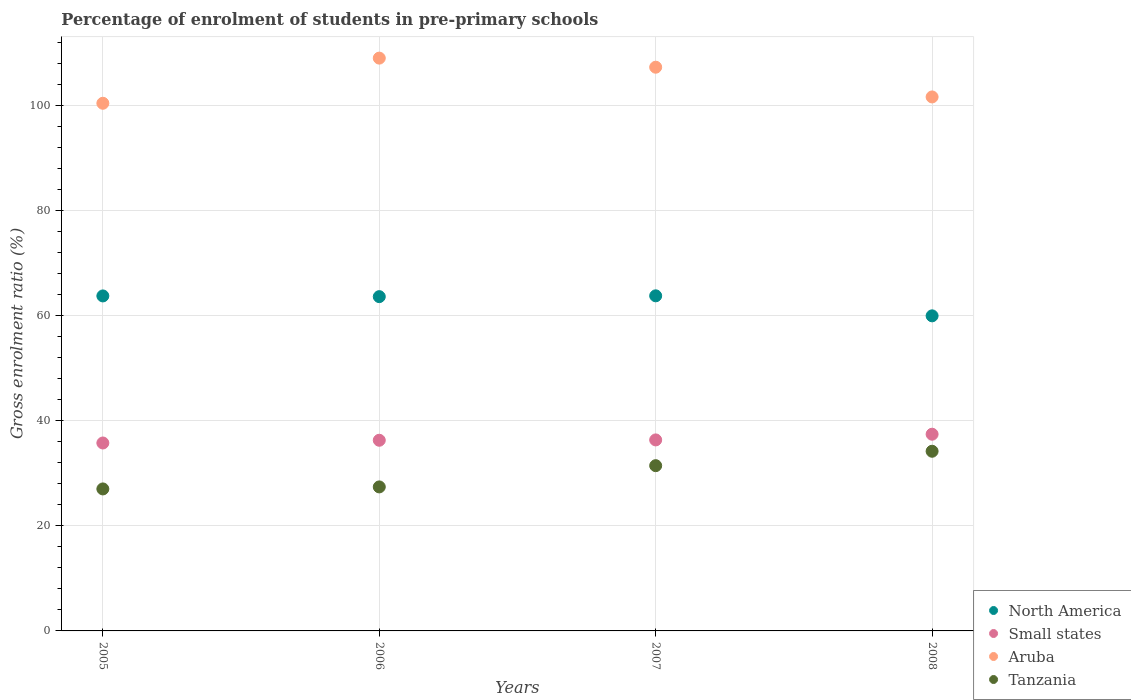How many different coloured dotlines are there?
Your answer should be compact. 4. What is the percentage of students enrolled in pre-primary schools in North America in 2005?
Offer a very short reply. 63.76. Across all years, what is the maximum percentage of students enrolled in pre-primary schools in Tanzania?
Your answer should be very brief. 34.2. Across all years, what is the minimum percentage of students enrolled in pre-primary schools in North America?
Give a very brief answer. 59.97. In which year was the percentage of students enrolled in pre-primary schools in North America minimum?
Ensure brevity in your answer.  2008. What is the total percentage of students enrolled in pre-primary schools in Small states in the graph?
Your answer should be very brief. 145.85. What is the difference between the percentage of students enrolled in pre-primary schools in North America in 2005 and that in 2007?
Offer a very short reply. -0.02. What is the difference between the percentage of students enrolled in pre-primary schools in North America in 2006 and the percentage of students enrolled in pre-primary schools in Aruba in 2005?
Keep it short and to the point. -36.8. What is the average percentage of students enrolled in pre-primary schools in Aruba per year?
Your answer should be very brief. 104.59. In the year 2007, what is the difference between the percentage of students enrolled in pre-primary schools in Aruba and percentage of students enrolled in pre-primary schools in Small states?
Ensure brevity in your answer.  70.94. What is the ratio of the percentage of students enrolled in pre-primary schools in Small states in 2006 to that in 2008?
Provide a short and direct response. 0.97. What is the difference between the highest and the second highest percentage of students enrolled in pre-primary schools in Aruba?
Your answer should be very brief. 1.73. What is the difference between the highest and the lowest percentage of students enrolled in pre-primary schools in Aruba?
Offer a terse response. 8.59. Is the sum of the percentage of students enrolled in pre-primary schools in Small states in 2006 and 2008 greater than the maximum percentage of students enrolled in pre-primary schools in North America across all years?
Ensure brevity in your answer.  Yes. Is the percentage of students enrolled in pre-primary schools in North America strictly less than the percentage of students enrolled in pre-primary schools in Tanzania over the years?
Offer a terse response. No. How many dotlines are there?
Your response must be concise. 4. What is the difference between two consecutive major ticks on the Y-axis?
Give a very brief answer. 20. Are the values on the major ticks of Y-axis written in scientific E-notation?
Offer a terse response. No. Where does the legend appear in the graph?
Make the answer very short. Bottom right. How are the legend labels stacked?
Keep it short and to the point. Vertical. What is the title of the graph?
Your answer should be compact. Percentage of enrolment of students in pre-primary schools. Does "Maldives" appear as one of the legend labels in the graph?
Make the answer very short. No. What is the label or title of the Y-axis?
Provide a succinct answer. Gross enrolment ratio (%). What is the Gross enrolment ratio (%) of North America in 2005?
Your response must be concise. 63.76. What is the Gross enrolment ratio (%) in Small states in 2005?
Your answer should be compact. 35.77. What is the Gross enrolment ratio (%) in Aruba in 2005?
Your response must be concise. 100.43. What is the Gross enrolment ratio (%) of Tanzania in 2005?
Offer a very short reply. 27.02. What is the Gross enrolment ratio (%) of North America in 2006?
Keep it short and to the point. 63.62. What is the Gross enrolment ratio (%) in Small states in 2006?
Your answer should be compact. 36.29. What is the Gross enrolment ratio (%) of Aruba in 2006?
Your answer should be very brief. 109.02. What is the Gross enrolment ratio (%) of Tanzania in 2006?
Offer a very short reply. 27.41. What is the Gross enrolment ratio (%) of North America in 2007?
Provide a short and direct response. 63.78. What is the Gross enrolment ratio (%) in Small states in 2007?
Your answer should be compact. 36.35. What is the Gross enrolment ratio (%) in Aruba in 2007?
Ensure brevity in your answer.  107.29. What is the Gross enrolment ratio (%) in Tanzania in 2007?
Give a very brief answer. 31.45. What is the Gross enrolment ratio (%) in North America in 2008?
Keep it short and to the point. 59.97. What is the Gross enrolment ratio (%) of Small states in 2008?
Provide a succinct answer. 37.44. What is the Gross enrolment ratio (%) in Aruba in 2008?
Offer a terse response. 101.63. What is the Gross enrolment ratio (%) in Tanzania in 2008?
Your answer should be very brief. 34.2. Across all years, what is the maximum Gross enrolment ratio (%) in North America?
Your response must be concise. 63.78. Across all years, what is the maximum Gross enrolment ratio (%) in Small states?
Make the answer very short. 37.44. Across all years, what is the maximum Gross enrolment ratio (%) of Aruba?
Ensure brevity in your answer.  109.02. Across all years, what is the maximum Gross enrolment ratio (%) of Tanzania?
Make the answer very short. 34.2. Across all years, what is the minimum Gross enrolment ratio (%) of North America?
Provide a short and direct response. 59.97. Across all years, what is the minimum Gross enrolment ratio (%) in Small states?
Keep it short and to the point. 35.77. Across all years, what is the minimum Gross enrolment ratio (%) of Aruba?
Ensure brevity in your answer.  100.43. Across all years, what is the minimum Gross enrolment ratio (%) in Tanzania?
Your answer should be very brief. 27.02. What is the total Gross enrolment ratio (%) in North America in the graph?
Give a very brief answer. 251.13. What is the total Gross enrolment ratio (%) in Small states in the graph?
Your answer should be compact. 145.85. What is the total Gross enrolment ratio (%) of Aruba in the graph?
Your answer should be very brief. 418.37. What is the total Gross enrolment ratio (%) in Tanzania in the graph?
Ensure brevity in your answer.  120.08. What is the difference between the Gross enrolment ratio (%) in North America in 2005 and that in 2006?
Give a very brief answer. 0.14. What is the difference between the Gross enrolment ratio (%) in Small states in 2005 and that in 2006?
Give a very brief answer. -0.52. What is the difference between the Gross enrolment ratio (%) of Aruba in 2005 and that in 2006?
Make the answer very short. -8.59. What is the difference between the Gross enrolment ratio (%) in Tanzania in 2005 and that in 2006?
Offer a very short reply. -0.38. What is the difference between the Gross enrolment ratio (%) of North America in 2005 and that in 2007?
Provide a succinct answer. -0.02. What is the difference between the Gross enrolment ratio (%) of Small states in 2005 and that in 2007?
Your answer should be compact. -0.59. What is the difference between the Gross enrolment ratio (%) of Aruba in 2005 and that in 2007?
Give a very brief answer. -6.86. What is the difference between the Gross enrolment ratio (%) in Tanzania in 2005 and that in 2007?
Offer a terse response. -4.43. What is the difference between the Gross enrolment ratio (%) of North America in 2005 and that in 2008?
Offer a terse response. 3.79. What is the difference between the Gross enrolment ratio (%) in Small states in 2005 and that in 2008?
Provide a succinct answer. -1.67. What is the difference between the Gross enrolment ratio (%) in Aruba in 2005 and that in 2008?
Your answer should be compact. -1.2. What is the difference between the Gross enrolment ratio (%) in Tanzania in 2005 and that in 2008?
Offer a terse response. -7.17. What is the difference between the Gross enrolment ratio (%) of North America in 2006 and that in 2007?
Your response must be concise. -0.16. What is the difference between the Gross enrolment ratio (%) in Small states in 2006 and that in 2007?
Make the answer very short. -0.07. What is the difference between the Gross enrolment ratio (%) in Aruba in 2006 and that in 2007?
Give a very brief answer. 1.73. What is the difference between the Gross enrolment ratio (%) of Tanzania in 2006 and that in 2007?
Offer a terse response. -4.04. What is the difference between the Gross enrolment ratio (%) of North America in 2006 and that in 2008?
Your response must be concise. 3.65. What is the difference between the Gross enrolment ratio (%) of Small states in 2006 and that in 2008?
Your answer should be very brief. -1.15. What is the difference between the Gross enrolment ratio (%) in Aruba in 2006 and that in 2008?
Ensure brevity in your answer.  7.39. What is the difference between the Gross enrolment ratio (%) of Tanzania in 2006 and that in 2008?
Offer a very short reply. -6.79. What is the difference between the Gross enrolment ratio (%) in North America in 2007 and that in 2008?
Your response must be concise. 3.81. What is the difference between the Gross enrolment ratio (%) of Small states in 2007 and that in 2008?
Offer a very short reply. -1.09. What is the difference between the Gross enrolment ratio (%) in Aruba in 2007 and that in 2008?
Offer a terse response. 5.66. What is the difference between the Gross enrolment ratio (%) of Tanzania in 2007 and that in 2008?
Make the answer very short. -2.74. What is the difference between the Gross enrolment ratio (%) of North America in 2005 and the Gross enrolment ratio (%) of Small states in 2006?
Make the answer very short. 27.47. What is the difference between the Gross enrolment ratio (%) in North America in 2005 and the Gross enrolment ratio (%) in Aruba in 2006?
Ensure brevity in your answer.  -45.26. What is the difference between the Gross enrolment ratio (%) of North America in 2005 and the Gross enrolment ratio (%) of Tanzania in 2006?
Keep it short and to the point. 36.35. What is the difference between the Gross enrolment ratio (%) in Small states in 2005 and the Gross enrolment ratio (%) in Aruba in 2006?
Provide a succinct answer. -73.25. What is the difference between the Gross enrolment ratio (%) of Small states in 2005 and the Gross enrolment ratio (%) of Tanzania in 2006?
Provide a succinct answer. 8.36. What is the difference between the Gross enrolment ratio (%) of Aruba in 2005 and the Gross enrolment ratio (%) of Tanzania in 2006?
Give a very brief answer. 73.02. What is the difference between the Gross enrolment ratio (%) in North America in 2005 and the Gross enrolment ratio (%) in Small states in 2007?
Keep it short and to the point. 27.4. What is the difference between the Gross enrolment ratio (%) in North America in 2005 and the Gross enrolment ratio (%) in Aruba in 2007?
Ensure brevity in your answer.  -43.53. What is the difference between the Gross enrolment ratio (%) of North America in 2005 and the Gross enrolment ratio (%) of Tanzania in 2007?
Keep it short and to the point. 32.31. What is the difference between the Gross enrolment ratio (%) of Small states in 2005 and the Gross enrolment ratio (%) of Aruba in 2007?
Your response must be concise. -71.52. What is the difference between the Gross enrolment ratio (%) in Small states in 2005 and the Gross enrolment ratio (%) in Tanzania in 2007?
Ensure brevity in your answer.  4.32. What is the difference between the Gross enrolment ratio (%) in Aruba in 2005 and the Gross enrolment ratio (%) in Tanzania in 2007?
Your response must be concise. 68.98. What is the difference between the Gross enrolment ratio (%) of North America in 2005 and the Gross enrolment ratio (%) of Small states in 2008?
Offer a terse response. 26.32. What is the difference between the Gross enrolment ratio (%) of North America in 2005 and the Gross enrolment ratio (%) of Aruba in 2008?
Give a very brief answer. -37.87. What is the difference between the Gross enrolment ratio (%) in North America in 2005 and the Gross enrolment ratio (%) in Tanzania in 2008?
Give a very brief answer. 29.56. What is the difference between the Gross enrolment ratio (%) of Small states in 2005 and the Gross enrolment ratio (%) of Aruba in 2008?
Your answer should be very brief. -65.86. What is the difference between the Gross enrolment ratio (%) of Small states in 2005 and the Gross enrolment ratio (%) of Tanzania in 2008?
Make the answer very short. 1.57. What is the difference between the Gross enrolment ratio (%) of Aruba in 2005 and the Gross enrolment ratio (%) of Tanzania in 2008?
Keep it short and to the point. 66.23. What is the difference between the Gross enrolment ratio (%) of North America in 2006 and the Gross enrolment ratio (%) of Small states in 2007?
Offer a terse response. 27.27. What is the difference between the Gross enrolment ratio (%) in North America in 2006 and the Gross enrolment ratio (%) in Aruba in 2007?
Provide a succinct answer. -43.67. What is the difference between the Gross enrolment ratio (%) in North America in 2006 and the Gross enrolment ratio (%) in Tanzania in 2007?
Provide a succinct answer. 32.17. What is the difference between the Gross enrolment ratio (%) in Small states in 2006 and the Gross enrolment ratio (%) in Aruba in 2007?
Offer a very short reply. -71. What is the difference between the Gross enrolment ratio (%) of Small states in 2006 and the Gross enrolment ratio (%) of Tanzania in 2007?
Keep it short and to the point. 4.84. What is the difference between the Gross enrolment ratio (%) in Aruba in 2006 and the Gross enrolment ratio (%) in Tanzania in 2007?
Your response must be concise. 77.57. What is the difference between the Gross enrolment ratio (%) of North America in 2006 and the Gross enrolment ratio (%) of Small states in 2008?
Offer a terse response. 26.18. What is the difference between the Gross enrolment ratio (%) of North America in 2006 and the Gross enrolment ratio (%) of Aruba in 2008?
Make the answer very short. -38.01. What is the difference between the Gross enrolment ratio (%) in North America in 2006 and the Gross enrolment ratio (%) in Tanzania in 2008?
Your answer should be compact. 29.43. What is the difference between the Gross enrolment ratio (%) in Small states in 2006 and the Gross enrolment ratio (%) in Aruba in 2008?
Keep it short and to the point. -65.34. What is the difference between the Gross enrolment ratio (%) of Small states in 2006 and the Gross enrolment ratio (%) of Tanzania in 2008?
Your answer should be compact. 2.09. What is the difference between the Gross enrolment ratio (%) in Aruba in 2006 and the Gross enrolment ratio (%) in Tanzania in 2008?
Offer a very short reply. 74.83. What is the difference between the Gross enrolment ratio (%) in North America in 2007 and the Gross enrolment ratio (%) in Small states in 2008?
Give a very brief answer. 26.34. What is the difference between the Gross enrolment ratio (%) in North America in 2007 and the Gross enrolment ratio (%) in Aruba in 2008?
Provide a succinct answer. -37.85. What is the difference between the Gross enrolment ratio (%) in North America in 2007 and the Gross enrolment ratio (%) in Tanzania in 2008?
Keep it short and to the point. 29.58. What is the difference between the Gross enrolment ratio (%) of Small states in 2007 and the Gross enrolment ratio (%) of Aruba in 2008?
Provide a short and direct response. -65.28. What is the difference between the Gross enrolment ratio (%) in Small states in 2007 and the Gross enrolment ratio (%) in Tanzania in 2008?
Provide a succinct answer. 2.16. What is the difference between the Gross enrolment ratio (%) in Aruba in 2007 and the Gross enrolment ratio (%) in Tanzania in 2008?
Ensure brevity in your answer.  73.09. What is the average Gross enrolment ratio (%) of North America per year?
Give a very brief answer. 62.78. What is the average Gross enrolment ratio (%) of Small states per year?
Ensure brevity in your answer.  36.46. What is the average Gross enrolment ratio (%) in Aruba per year?
Provide a short and direct response. 104.59. What is the average Gross enrolment ratio (%) of Tanzania per year?
Make the answer very short. 30.02. In the year 2005, what is the difference between the Gross enrolment ratio (%) of North America and Gross enrolment ratio (%) of Small states?
Provide a succinct answer. 27.99. In the year 2005, what is the difference between the Gross enrolment ratio (%) in North America and Gross enrolment ratio (%) in Aruba?
Keep it short and to the point. -36.67. In the year 2005, what is the difference between the Gross enrolment ratio (%) of North America and Gross enrolment ratio (%) of Tanzania?
Your answer should be very brief. 36.73. In the year 2005, what is the difference between the Gross enrolment ratio (%) in Small states and Gross enrolment ratio (%) in Aruba?
Provide a short and direct response. -64.66. In the year 2005, what is the difference between the Gross enrolment ratio (%) of Small states and Gross enrolment ratio (%) of Tanzania?
Give a very brief answer. 8.74. In the year 2005, what is the difference between the Gross enrolment ratio (%) of Aruba and Gross enrolment ratio (%) of Tanzania?
Provide a short and direct response. 73.4. In the year 2006, what is the difference between the Gross enrolment ratio (%) in North America and Gross enrolment ratio (%) in Small states?
Give a very brief answer. 27.33. In the year 2006, what is the difference between the Gross enrolment ratio (%) in North America and Gross enrolment ratio (%) in Aruba?
Offer a terse response. -45.4. In the year 2006, what is the difference between the Gross enrolment ratio (%) in North America and Gross enrolment ratio (%) in Tanzania?
Keep it short and to the point. 36.21. In the year 2006, what is the difference between the Gross enrolment ratio (%) in Small states and Gross enrolment ratio (%) in Aruba?
Provide a succinct answer. -72.73. In the year 2006, what is the difference between the Gross enrolment ratio (%) of Small states and Gross enrolment ratio (%) of Tanzania?
Your answer should be very brief. 8.88. In the year 2006, what is the difference between the Gross enrolment ratio (%) of Aruba and Gross enrolment ratio (%) of Tanzania?
Make the answer very short. 81.61. In the year 2007, what is the difference between the Gross enrolment ratio (%) of North America and Gross enrolment ratio (%) of Small states?
Your response must be concise. 27.42. In the year 2007, what is the difference between the Gross enrolment ratio (%) of North America and Gross enrolment ratio (%) of Aruba?
Keep it short and to the point. -43.51. In the year 2007, what is the difference between the Gross enrolment ratio (%) of North America and Gross enrolment ratio (%) of Tanzania?
Provide a short and direct response. 32.33. In the year 2007, what is the difference between the Gross enrolment ratio (%) of Small states and Gross enrolment ratio (%) of Aruba?
Ensure brevity in your answer.  -70.94. In the year 2007, what is the difference between the Gross enrolment ratio (%) in Small states and Gross enrolment ratio (%) in Tanzania?
Ensure brevity in your answer.  4.9. In the year 2007, what is the difference between the Gross enrolment ratio (%) of Aruba and Gross enrolment ratio (%) of Tanzania?
Keep it short and to the point. 75.84. In the year 2008, what is the difference between the Gross enrolment ratio (%) of North America and Gross enrolment ratio (%) of Small states?
Your answer should be compact. 22.53. In the year 2008, what is the difference between the Gross enrolment ratio (%) in North America and Gross enrolment ratio (%) in Aruba?
Keep it short and to the point. -41.66. In the year 2008, what is the difference between the Gross enrolment ratio (%) of North America and Gross enrolment ratio (%) of Tanzania?
Keep it short and to the point. 25.77. In the year 2008, what is the difference between the Gross enrolment ratio (%) in Small states and Gross enrolment ratio (%) in Aruba?
Ensure brevity in your answer.  -64.19. In the year 2008, what is the difference between the Gross enrolment ratio (%) of Small states and Gross enrolment ratio (%) of Tanzania?
Your response must be concise. 3.24. In the year 2008, what is the difference between the Gross enrolment ratio (%) of Aruba and Gross enrolment ratio (%) of Tanzania?
Keep it short and to the point. 67.44. What is the ratio of the Gross enrolment ratio (%) in Small states in 2005 to that in 2006?
Offer a very short reply. 0.99. What is the ratio of the Gross enrolment ratio (%) in Aruba in 2005 to that in 2006?
Provide a succinct answer. 0.92. What is the ratio of the Gross enrolment ratio (%) of Tanzania in 2005 to that in 2006?
Offer a very short reply. 0.99. What is the ratio of the Gross enrolment ratio (%) in North America in 2005 to that in 2007?
Your response must be concise. 1. What is the ratio of the Gross enrolment ratio (%) of Small states in 2005 to that in 2007?
Provide a short and direct response. 0.98. What is the ratio of the Gross enrolment ratio (%) in Aruba in 2005 to that in 2007?
Give a very brief answer. 0.94. What is the ratio of the Gross enrolment ratio (%) of Tanzania in 2005 to that in 2007?
Make the answer very short. 0.86. What is the ratio of the Gross enrolment ratio (%) of North America in 2005 to that in 2008?
Ensure brevity in your answer.  1.06. What is the ratio of the Gross enrolment ratio (%) in Small states in 2005 to that in 2008?
Your response must be concise. 0.96. What is the ratio of the Gross enrolment ratio (%) in Aruba in 2005 to that in 2008?
Give a very brief answer. 0.99. What is the ratio of the Gross enrolment ratio (%) in Tanzania in 2005 to that in 2008?
Provide a short and direct response. 0.79. What is the ratio of the Gross enrolment ratio (%) of North America in 2006 to that in 2007?
Offer a terse response. 1. What is the ratio of the Gross enrolment ratio (%) of Aruba in 2006 to that in 2007?
Make the answer very short. 1.02. What is the ratio of the Gross enrolment ratio (%) in Tanzania in 2006 to that in 2007?
Offer a terse response. 0.87. What is the ratio of the Gross enrolment ratio (%) of North America in 2006 to that in 2008?
Your answer should be very brief. 1.06. What is the ratio of the Gross enrolment ratio (%) in Small states in 2006 to that in 2008?
Your answer should be compact. 0.97. What is the ratio of the Gross enrolment ratio (%) of Aruba in 2006 to that in 2008?
Make the answer very short. 1.07. What is the ratio of the Gross enrolment ratio (%) of Tanzania in 2006 to that in 2008?
Ensure brevity in your answer.  0.8. What is the ratio of the Gross enrolment ratio (%) in North America in 2007 to that in 2008?
Provide a short and direct response. 1.06. What is the ratio of the Gross enrolment ratio (%) of Small states in 2007 to that in 2008?
Your answer should be compact. 0.97. What is the ratio of the Gross enrolment ratio (%) of Aruba in 2007 to that in 2008?
Your answer should be very brief. 1.06. What is the ratio of the Gross enrolment ratio (%) of Tanzania in 2007 to that in 2008?
Provide a succinct answer. 0.92. What is the difference between the highest and the second highest Gross enrolment ratio (%) in North America?
Your answer should be very brief. 0.02. What is the difference between the highest and the second highest Gross enrolment ratio (%) of Small states?
Your answer should be very brief. 1.09. What is the difference between the highest and the second highest Gross enrolment ratio (%) in Aruba?
Keep it short and to the point. 1.73. What is the difference between the highest and the second highest Gross enrolment ratio (%) in Tanzania?
Offer a terse response. 2.74. What is the difference between the highest and the lowest Gross enrolment ratio (%) in North America?
Offer a terse response. 3.81. What is the difference between the highest and the lowest Gross enrolment ratio (%) of Small states?
Keep it short and to the point. 1.67. What is the difference between the highest and the lowest Gross enrolment ratio (%) of Aruba?
Make the answer very short. 8.59. What is the difference between the highest and the lowest Gross enrolment ratio (%) in Tanzania?
Offer a very short reply. 7.17. 